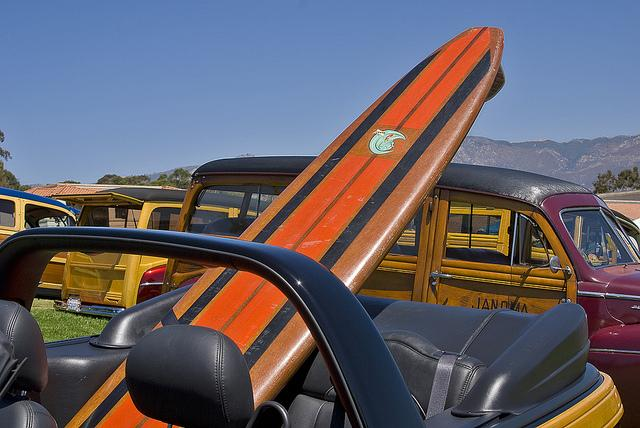Who played the character on the Brady Bunch whose name can be spelled with the first three letters shown on the vehicle? eve plumb 